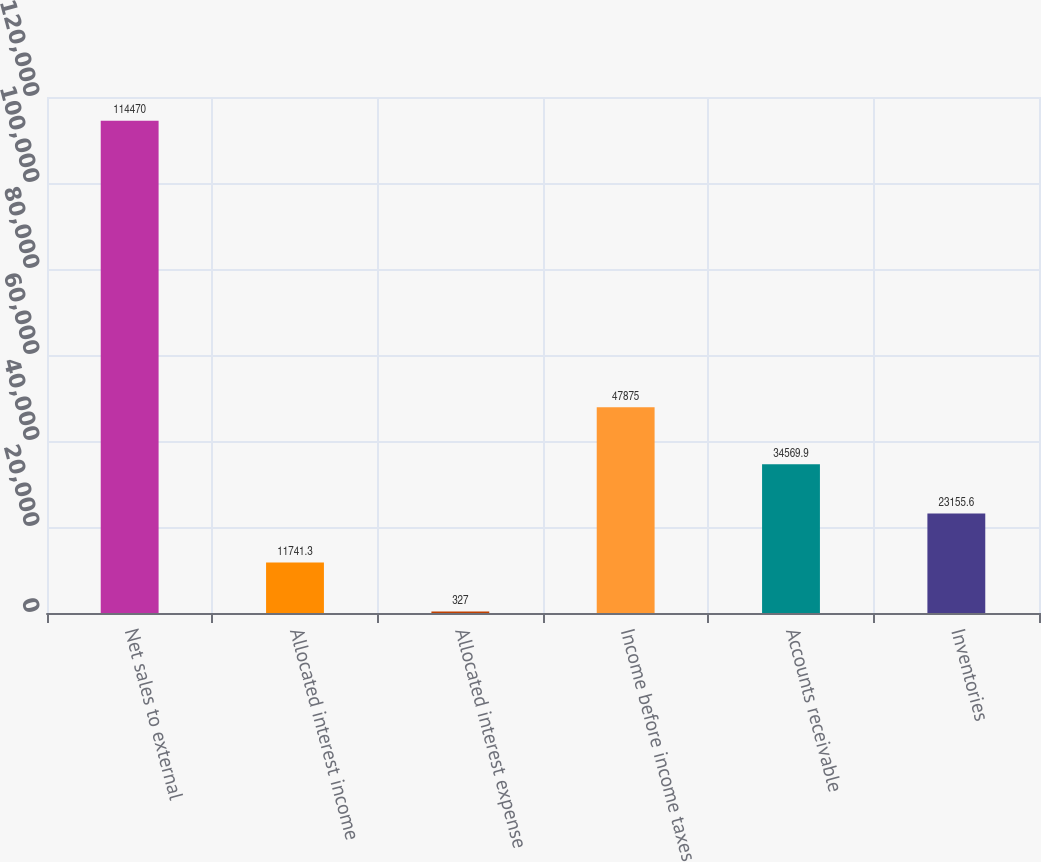Convert chart. <chart><loc_0><loc_0><loc_500><loc_500><bar_chart><fcel>Net sales to external<fcel>Allocated interest income<fcel>Allocated interest expense<fcel>Income before income taxes<fcel>Accounts receivable<fcel>Inventories<nl><fcel>114470<fcel>11741.3<fcel>327<fcel>47875<fcel>34569.9<fcel>23155.6<nl></chart> 